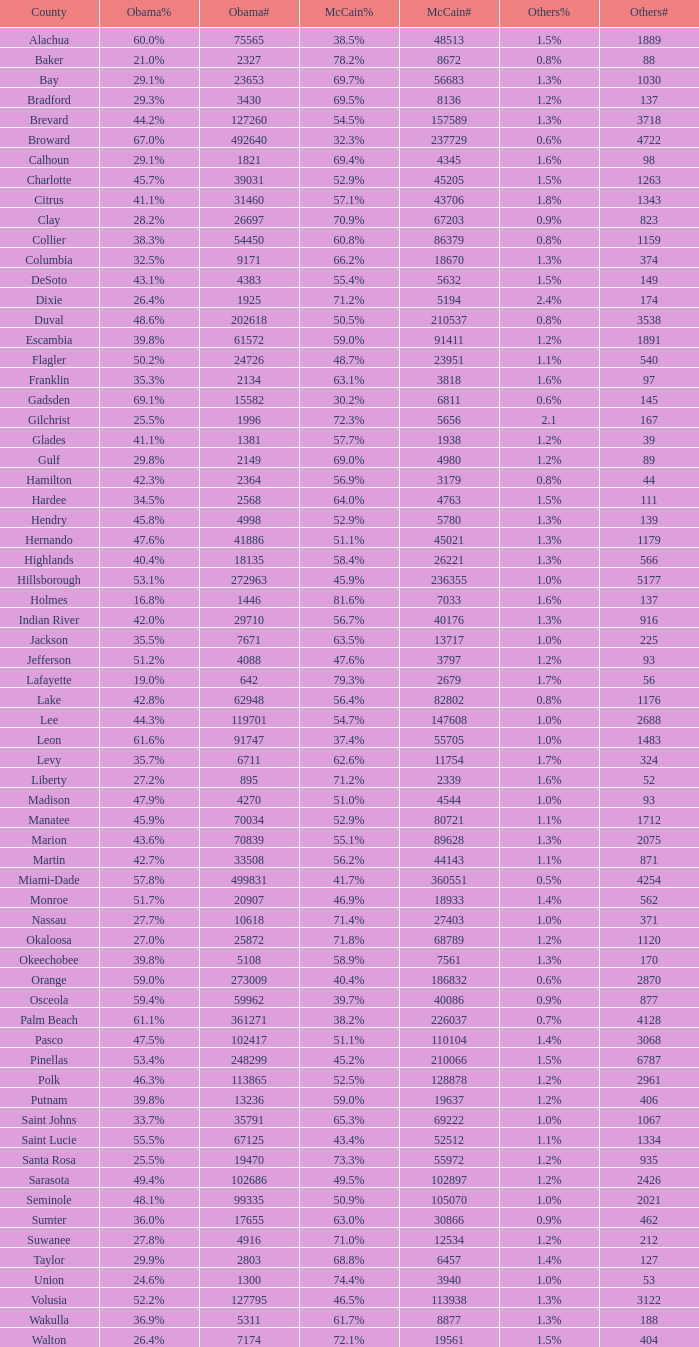With 29.9% voters under obama, how many numbers were documented? 1.0. 